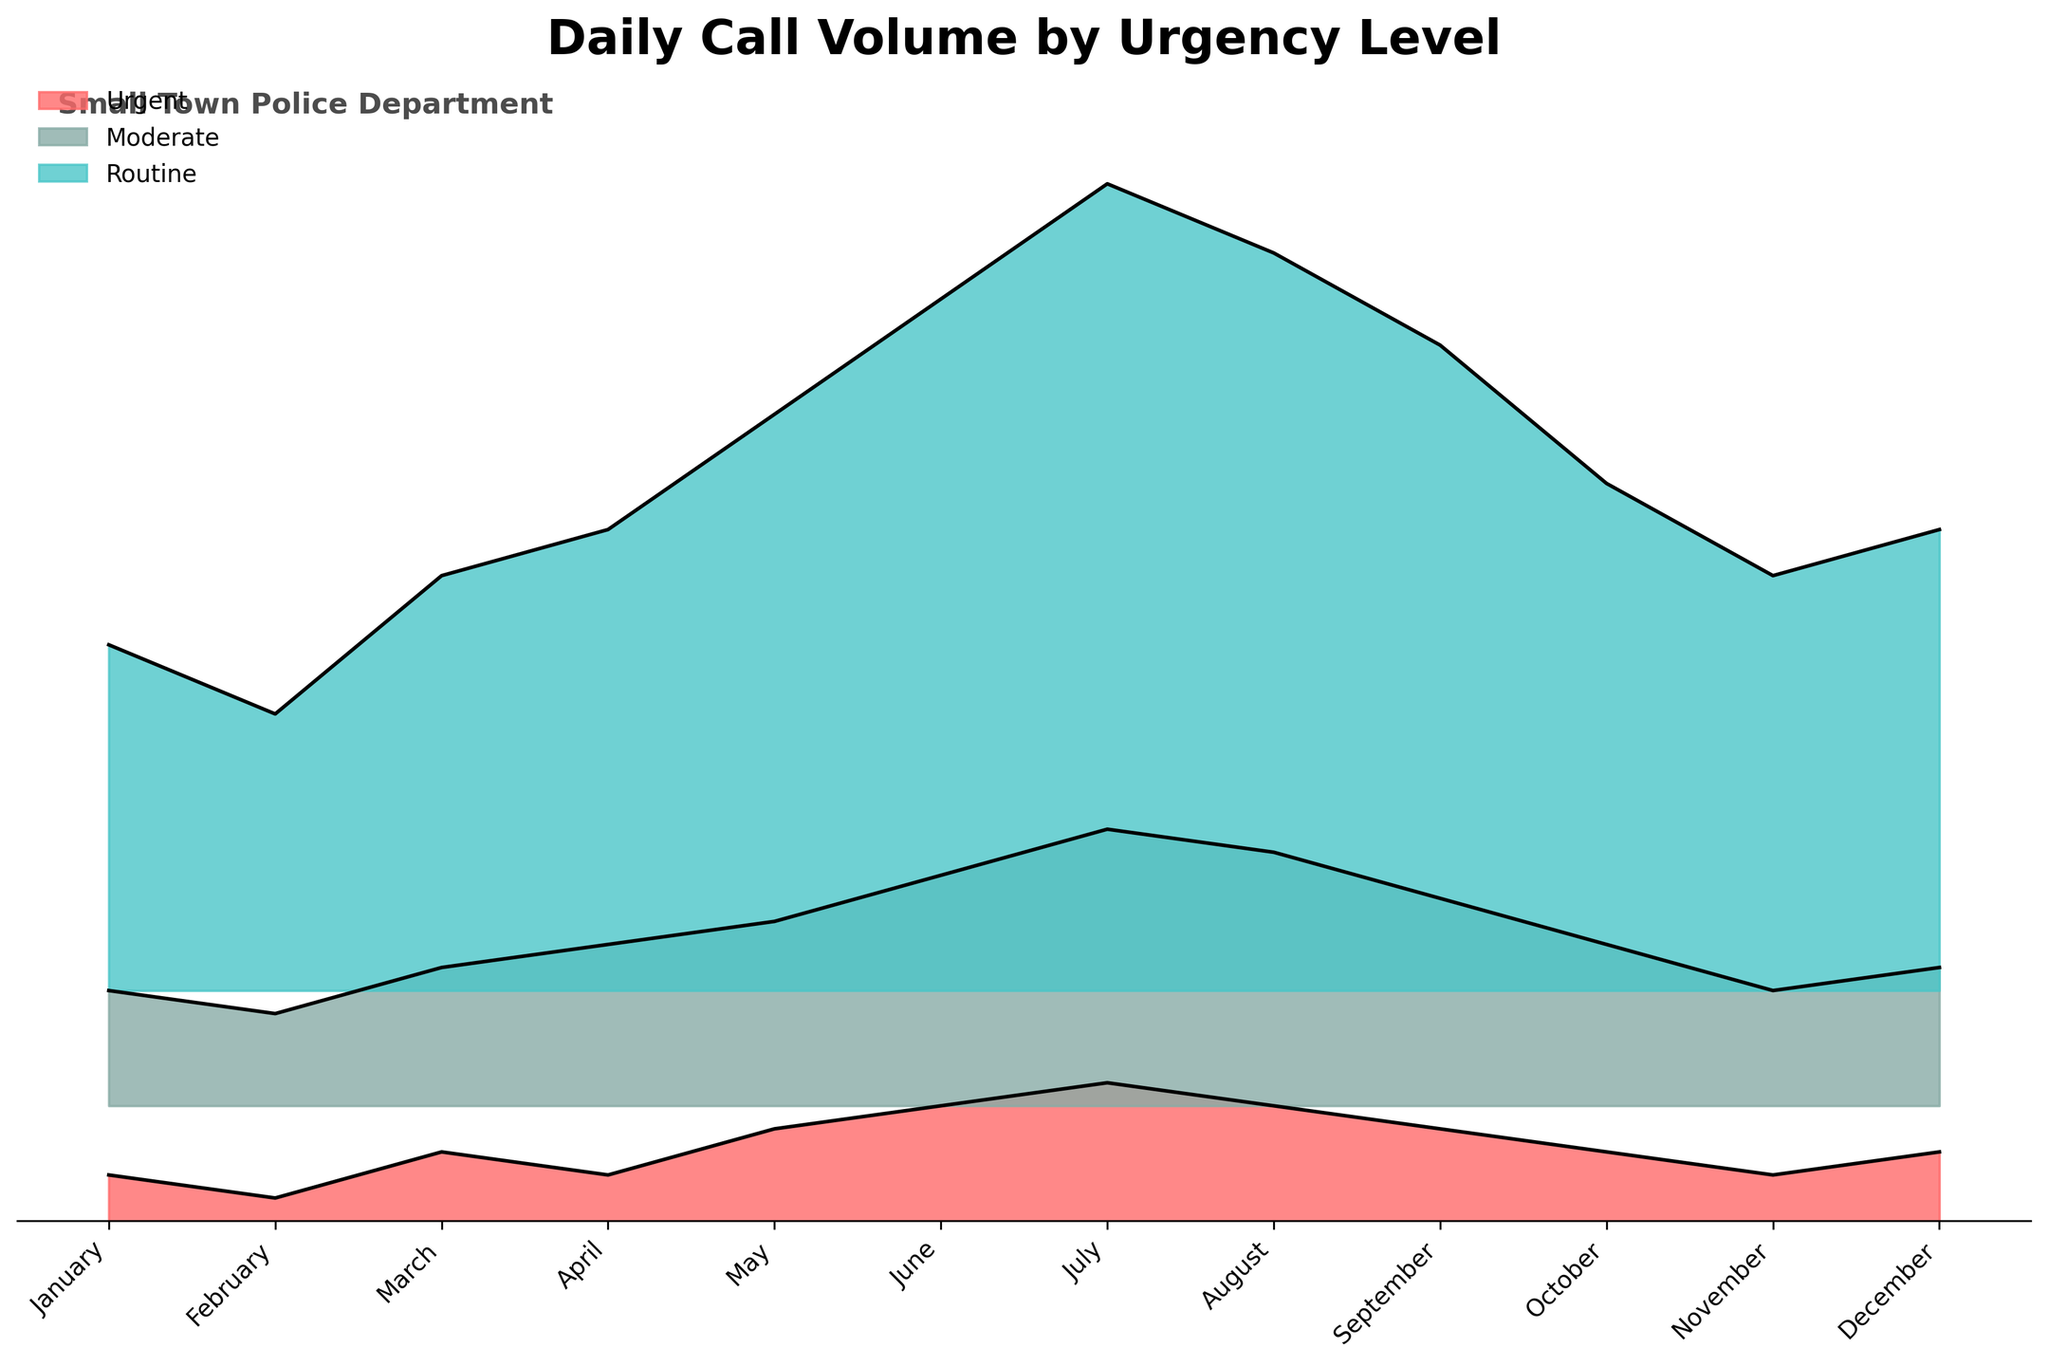How many urgency levels are represented in the plot? The title "Daily Call Volume by Urgency Level" and visual elements in the plot show three distinct colored areas representing different urgency levels.
Answer: 3 What is the color representing Routine calls? In the plot, the Routine calls are represented by a blueish color.
Answer: Blue In which month is the volume of Urgent calls the highest? Urgent calls are represented by the top layer in the plot, which peaks in July.
Answer: July What is the average call volume for Moderate urgency in the first quarter (January, February, March)? The call volumes for Moderate urgency in January, February, and March are 5, 4, and 6, respectively. The average is calculated as (5 + 4 + 6) / 3 = 15 / 3 = 5.
Answer: 5 How do call volumes in July compare across all urgency levels? In the plot, July shows the highest Urgent volume (6), Moderate volume (12), and Routine volume (35). Comparing across months, July shows the highest for all urgency levels.
Answer: Highest in all levels What months have equal volumes of Urgent calls? By examining the top layer of the plot, January and November each show 2 Urgent calls.
Answer: January and November Which urgency level shows the most significant increase in call volume from January to December? Comparing all layers from January to December, Routine calls increase from 15 to 20 (5 calls), Moderate calls increase from 5 to 6 (1 call), and Urgent calls increase from 2 to 3 (1 call). The highest increase is for Routine calls (5 calls).
Answer: Routine Calculate the total call volume for all urgency levels in June. June has 5 Urgent, 10 Moderate, and 30 Routine calls. The total is 5 + 10 + 30 = 45.
Answer: 45 Between which months do Routine calls decrease the most? Routine calls drop from July (35) to August (32), a decrease of 3 calls, which is the highest drop observed.
Answer: July to August 